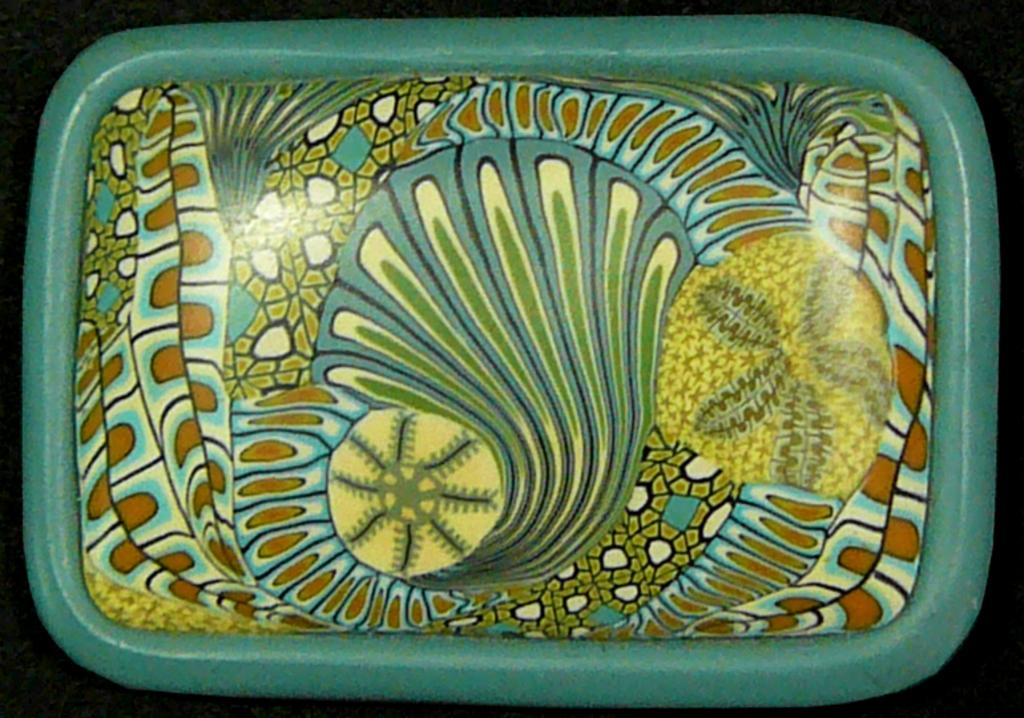What is the main object in the image that resembles a tray? There is an object in the image that looks like a tray with some design. What type of smell can be detected coming from the tray in the image? There is no indication of any smell in the image, as it is a visual representation and does not convey scents. 